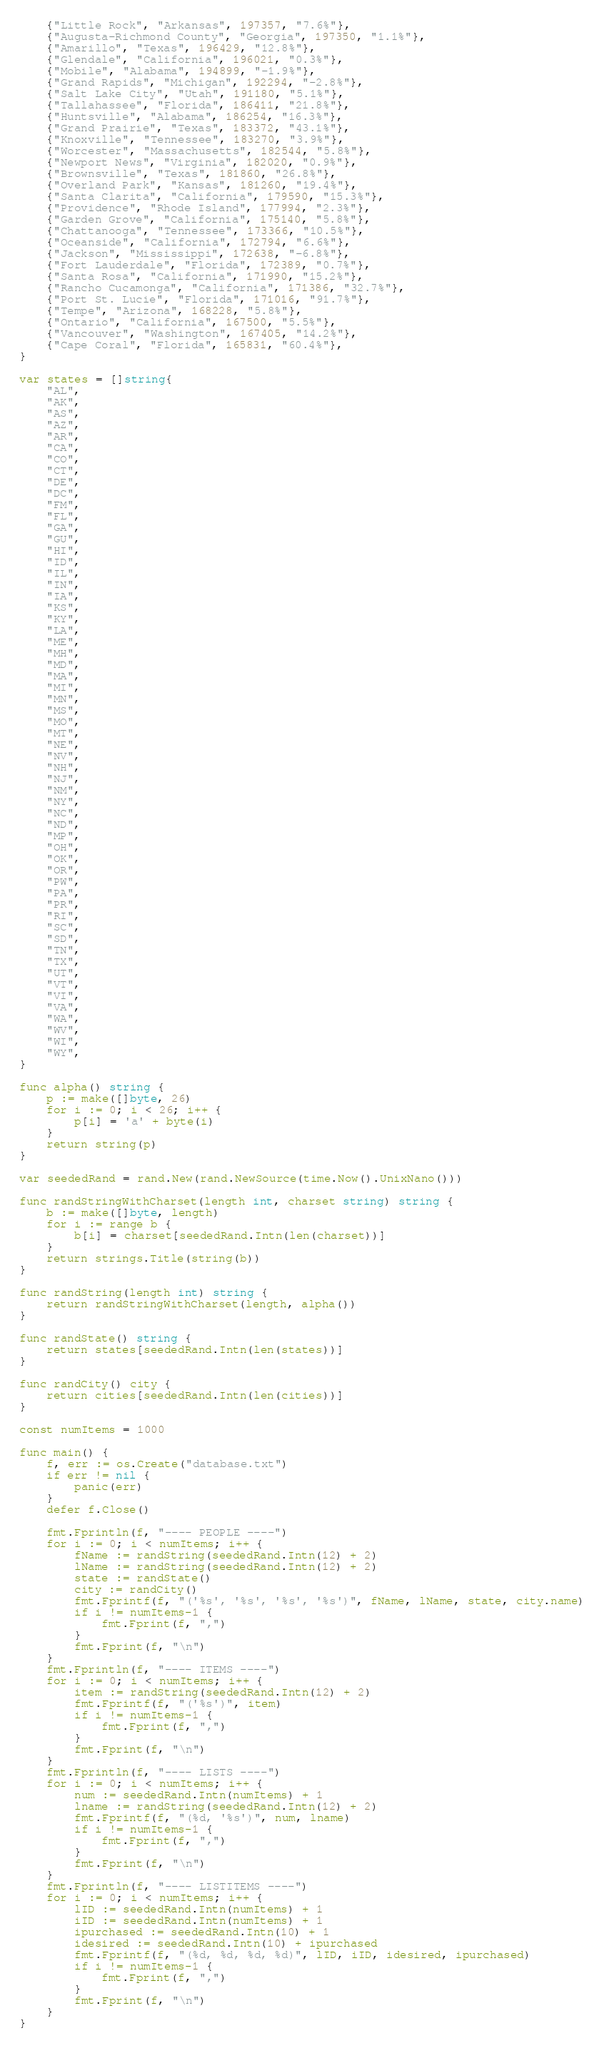Convert code to text. <code><loc_0><loc_0><loc_500><loc_500><_Go_>	{"Little Rock", "Arkansas", 197357, "7.6%"},
	{"Augusta-Richmond County", "Georgia", 197350, "1.1%"},
	{"Amarillo", "Texas", 196429, "12.8%"},
	{"Glendale", "California", 196021, "0.3%"},
	{"Mobile", "Alabama", 194899, "-1.9%"},
	{"Grand Rapids", "Michigan", 192294, "-2.8%"},
	{"Salt Lake City", "Utah", 191180, "5.1%"},
	{"Tallahassee", "Florida", 186411, "21.8%"},
	{"Huntsville", "Alabama", 186254, "16.3%"},
	{"Grand Prairie", "Texas", 183372, "43.1%"},
	{"Knoxville", "Tennessee", 183270, "3.9%"},
	{"Worcester", "Massachusetts", 182544, "5.8%"},
	{"Newport News", "Virginia", 182020, "0.9%"},
	{"Brownsville", "Texas", 181860, "26.8%"},
	{"Overland Park", "Kansas", 181260, "19.4%"},
	{"Santa Clarita", "California", 179590, "15.3%"},
	{"Providence", "Rhode Island", 177994, "2.3%"},
	{"Garden Grove", "California", 175140, "5.8%"},
	{"Chattanooga", "Tennessee", 173366, "10.5%"},
	{"Oceanside", "California", 172794, "6.6%"},
	{"Jackson", "Mississippi", 172638, "-6.8%"},
	{"Fort Lauderdale", "Florida", 172389, "0.7%"},
	{"Santa Rosa", "California", 171990, "15.2%"},
	{"Rancho Cucamonga", "California", 171386, "32.7%"},
	{"Port St. Lucie", "Florida", 171016, "91.7%"},
	{"Tempe", "Arizona", 168228, "5.8%"},
	{"Ontario", "California", 167500, "5.5%"},
	{"Vancouver", "Washington", 167405, "14.2%"},
	{"Cape Coral", "Florida", 165831, "60.4%"},
}

var states = []string{
	"AL",
	"AK",
	"AS",
	"AZ",
	"AR",
	"CA",
	"CO",
	"CT",
	"DE",
	"DC",
	"FM",
	"FL",
	"GA",
	"GU",
	"HI",
	"ID",
	"IL",
	"IN",
	"IA",
	"KS",
	"KY",
	"LA",
	"ME",
	"MH",
	"MD",
	"MA",
	"MI",
	"MN",
	"MS",
	"MO",
	"MT",
	"NE",
	"NV",
	"NH",
	"NJ",
	"NM",
	"NY",
	"NC",
	"ND",
	"MP",
	"OH",
	"OK",
	"OR",
	"PW",
	"PA",
	"PR",
	"RI",
	"SC",
	"SD",
	"TN",
	"TX",
	"UT",
	"VT",
	"VI",
	"VA",
	"WA",
	"WV",
	"WI",
	"WY",
}

func alpha() string {
	p := make([]byte, 26)
	for i := 0; i < 26; i++ {
		p[i] = 'a' + byte(i)
	}
	return string(p)
}

var seededRand = rand.New(rand.NewSource(time.Now().UnixNano()))

func randStringWithCharset(length int, charset string) string {
	b := make([]byte, length)
	for i := range b {
		b[i] = charset[seededRand.Intn(len(charset))]
	}
	return strings.Title(string(b))
}

func randString(length int) string {
	return randStringWithCharset(length, alpha())
}

func randState() string {
	return states[seededRand.Intn(len(states))]
}

func randCity() city {
	return cities[seededRand.Intn(len(cities))]
}

const numItems = 1000

func main() {
	f, err := os.Create("database.txt")
	if err != nil {
		panic(err)
	}
	defer f.Close()

	fmt.Fprintln(f, "---- PEOPLE ----")
	for i := 0; i < numItems; i++ {
		fName := randString(seededRand.Intn(12) + 2)
		lName := randString(seededRand.Intn(12) + 2)
		state := randState()
		city := randCity()
		fmt.Fprintf(f, "('%s', '%s', '%s', '%s')", fName, lName, state, city.name)
		if i != numItems-1 {
			fmt.Fprint(f, ",")
		}
		fmt.Fprint(f, "\n")
	}
	fmt.Fprintln(f, "---- ITEMS ----")
	for i := 0; i < numItems; i++ {
		item := randString(seededRand.Intn(12) + 2)
		fmt.Fprintf(f, "('%s')", item)
		if i != numItems-1 {
			fmt.Fprint(f, ",")
		}
		fmt.Fprint(f, "\n")
	}
	fmt.Fprintln(f, "---- LISTS ----")
	for i := 0; i < numItems; i++ {
		num := seededRand.Intn(numItems) + 1
		lname := randString(seededRand.Intn(12) + 2)
		fmt.Fprintf(f, "(%d, '%s')", num, lname)
		if i != numItems-1 {
			fmt.Fprint(f, ",")
		}
		fmt.Fprint(f, "\n")
	}
	fmt.Fprintln(f, "---- LISTITEMS ----")
	for i := 0; i < numItems; i++ {
		lID := seededRand.Intn(numItems) + 1
		iID := seededRand.Intn(numItems) + 1
		ipurchased := seededRand.Intn(10) + 1
		idesired := seededRand.Intn(10) + ipurchased
		fmt.Fprintf(f, "(%d, %d, %d, %d)", lID, iID, idesired, ipurchased)
		if i != numItems-1 {
			fmt.Fprint(f, ",")
		}
		fmt.Fprint(f, "\n")
	}
}</code> 